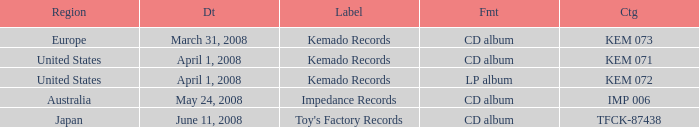Which Region has a Format of cd album, and a Label of kemado records, and a Catalog of kem 071? United States. 